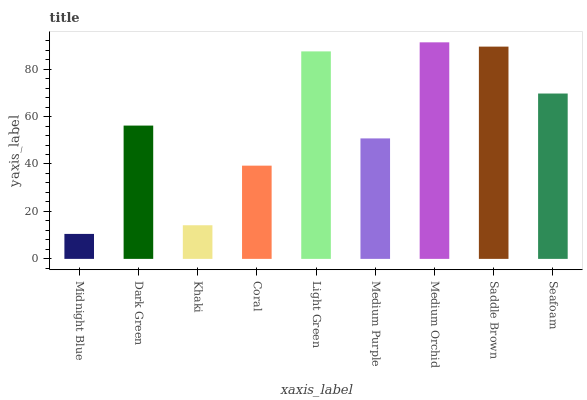Is Midnight Blue the minimum?
Answer yes or no. Yes. Is Medium Orchid the maximum?
Answer yes or no. Yes. Is Dark Green the minimum?
Answer yes or no. No. Is Dark Green the maximum?
Answer yes or no. No. Is Dark Green greater than Midnight Blue?
Answer yes or no. Yes. Is Midnight Blue less than Dark Green?
Answer yes or no. Yes. Is Midnight Blue greater than Dark Green?
Answer yes or no. No. Is Dark Green less than Midnight Blue?
Answer yes or no. No. Is Dark Green the high median?
Answer yes or no. Yes. Is Dark Green the low median?
Answer yes or no. Yes. Is Khaki the high median?
Answer yes or no. No. Is Medium Orchid the low median?
Answer yes or no. No. 